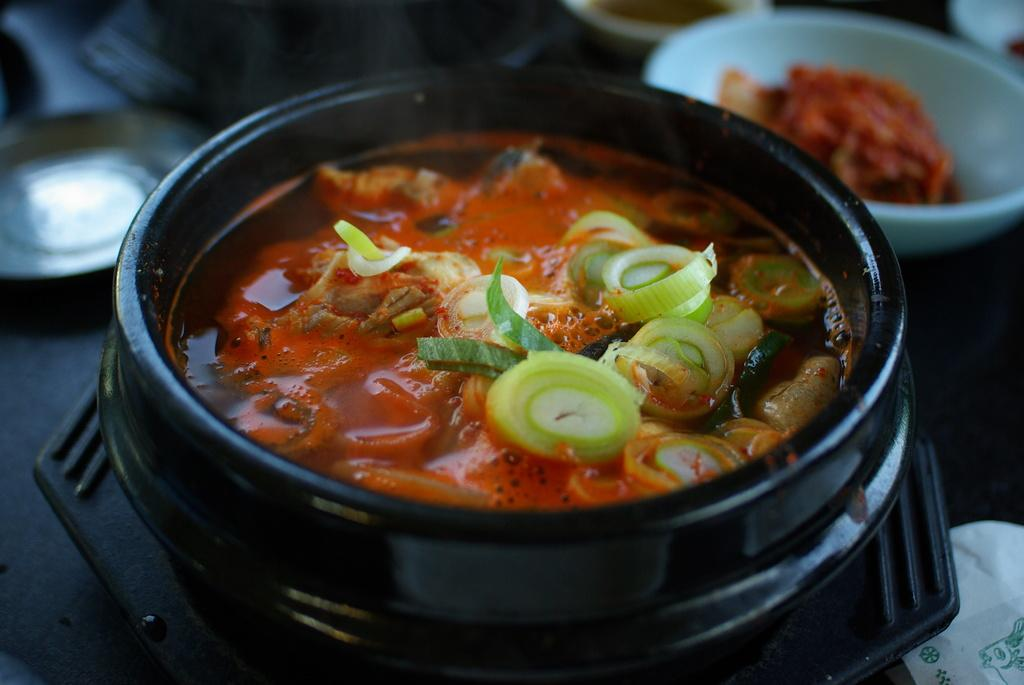What is in the serving bowl that is visible in the image? There is food in a serving bowl in the image. Where is the serving bowl located in the image? The serving bowl is placed on a table. What type of branch is used as a decoration in the office in the image? There is no branch or office present in the image; it only features a serving bowl with food on a table. 